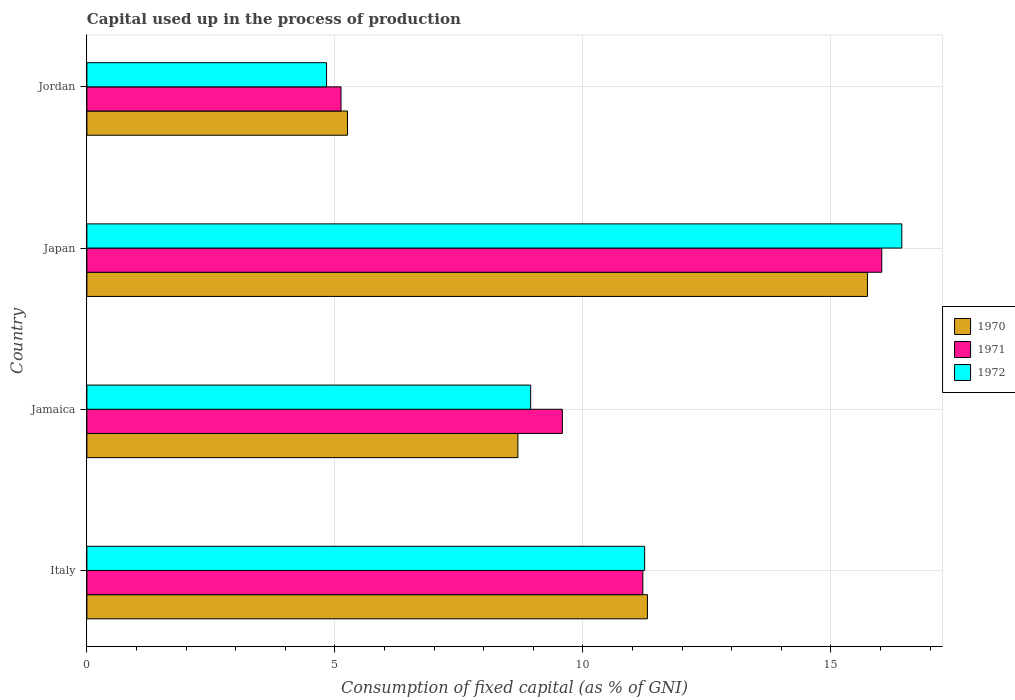How many different coloured bars are there?
Provide a succinct answer. 3. Are the number of bars per tick equal to the number of legend labels?
Offer a very short reply. Yes. What is the label of the 2nd group of bars from the top?
Your response must be concise. Japan. What is the capital used up in the process of production in 1972 in Jordan?
Provide a short and direct response. 4.83. Across all countries, what is the maximum capital used up in the process of production in 1970?
Provide a short and direct response. 15.74. Across all countries, what is the minimum capital used up in the process of production in 1972?
Your answer should be compact. 4.83. In which country was the capital used up in the process of production in 1972 maximum?
Offer a terse response. Japan. In which country was the capital used up in the process of production in 1971 minimum?
Give a very brief answer. Jordan. What is the total capital used up in the process of production in 1972 in the graph?
Ensure brevity in your answer.  41.45. What is the difference between the capital used up in the process of production in 1971 in Japan and that in Jordan?
Give a very brief answer. 10.9. What is the difference between the capital used up in the process of production in 1972 in Italy and the capital used up in the process of production in 1971 in Jordan?
Give a very brief answer. 6.12. What is the average capital used up in the process of production in 1972 per country?
Your answer should be very brief. 10.36. What is the difference between the capital used up in the process of production in 1970 and capital used up in the process of production in 1972 in Jordan?
Provide a succinct answer. 0.42. What is the ratio of the capital used up in the process of production in 1972 in Jamaica to that in Jordan?
Your answer should be very brief. 1.85. Is the capital used up in the process of production in 1970 in Italy less than that in Jordan?
Provide a short and direct response. No. Is the difference between the capital used up in the process of production in 1970 in Japan and Jordan greater than the difference between the capital used up in the process of production in 1972 in Japan and Jordan?
Your answer should be very brief. No. What is the difference between the highest and the second highest capital used up in the process of production in 1972?
Provide a succinct answer. 5.18. What is the difference between the highest and the lowest capital used up in the process of production in 1971?
Offer a terse response. 10.9. In how many countries, is the capital used up in the process of production in 1972 greater than the average capital used up in the process of production in 1972 taken over all countries?
Give a very brief answer. 2. Is the sum of the capital used up in the process of production in 1971 in Italy and Jordan greater than the maximum capital used up in the process of production in 1970 across all countries?
Your response must be concise. Yes. How many bars are there?
Offer a very short reply. 12. Are all the bars in the graph horizontal?
Keep it short and to the point. Yes. What is the difference between two consecutive major ticks on the X-axis?
Your answer should be very brief. 5. Are the values on the major ticks of X-axis written in scientific E-notation?
Your answer should be compact. No. Does the graph contain grids?
Offer a terse response. Yes. Where does the legend appear in the graph?
Your answer should be very brief. Center right. How many legend labels are there?
Offer a terse response. 3. How are the legend labels stacked?
Make the answer very short. Vertical. What is the title of the graph?
Offer a terse response. Capital used up in the process of production. Does "1961" appear as one of the legend labels in the graph?
Your answer should be compact. No. What is the label or title of the X-axis?
Your answer should be very brief. Consumption of fixed capital (as % of GNI). What is the Consumption of fixed capital (as % of GNI) of 1970 in Italy?
Offer a terse response. 11.3. What is the Consumption of fixed capital (as % of GNI) in 1971 in Italy?
Offer a very short reply. 11.21. What is the Consumption of fixed capital (as % of GNI) in 1972 in Italy?
Provide a succinct answer. 11.24. What is the Consumption of fixed capital (as % of GNI) of 1970 in Jamaica?
Offer a terse response. 8.69. What is the Consumption of fixed capital (as % of GNI) in 1971 in Jamaica?
Your answer should be compact. 9.58. What is the Consumption of fixed capital (as % of GNI) of 1972 in Jamaica?
Make the answer very short. 8.95. What is the Consumption of fixed capital (as % of GNI) of 1970 in Japan?
Make the answer very short. 15.74. What is the Consumption of fixed capital (as % of GNI) in 1971 in Japan?
Provide a short and direct response. 16.02. What is the Consumption of fixed capital (as % of GNI) of 1972 in Japan?
Your answer should be compact. 16.43. What is the Consumption of fixed capital (as % of GNI) of 1970 in Jordan?
Provide a succinct answer. 5.25. What is the Consumption of fixed capital (as % of GNI) in 1971 in Jordan?
Give a very brief answer. 5.12. What is the Consumption of fixed capital (as % of GNI) of 1972 in Jordan?
Your answer should be very brief. 4.83. Across all countries, what is the maximum Consumption of fixed capital (as % of GNI) in 1970?
Give a very brief answer. 15.74. Across all countries, what is the maximum Consumption of fixed capital (as % of GNI) of 1971?
Make the answer very short. 16.02. Across all countries, what is the maximum Consumption of fixed capital (as % of GNI) in 1972?
Your response must be concise. 16.43. Across all countries, what is the minimum Consumption of fixed capital (as % of GNI) of 1970?
Offer a terse response. 5.25. Across all countries, what is the minimum Consumption of fixed capital (as % of GNI) of 1971?
Ensure brevity in your answer.  5.12. Across all countries, what is the minimum Consumption of fixed capital (as % of GNI) in 1972?
Offer a very short reply. 4.83. What is the total Consumption of fixed capital (as % of GNI) of 1970 in the graph?
Keep it short and to the point. 40.98. What is the total Consumption of fixed capital (as % of GNI) in 1971 in the graph?
Your answer should be compact. 41.94. What is the total Consumption of fixed capital (as % of GNI) of 1972 in the graph?
Your response must be concise. 41.45. What is the difference between the Consumption of fixed capital (as % of GNI) of 1970 in Italy and that in Jamaica?
Provide a succinct answer. 2.61. What is the difference between the Consumption of fixed capital (as % of GNI) in 1971 in Italy and that in Jamaica?
Your answer should be very brief. 1.62. What is the difference between the Consumption of fixed capital (as % of GNI) of 1972 in Italy and that in Jamaica?
Your answer should be compact. 2.3. What is the difference between the Consumption of fixed capital (as % of GNI) of 1970 in Italy and that in Japan?
Offer a terse response. -4.44. What is the difference between the Consumption of fixed capital (as % of GNI) of 1971 in Italy and that in Japan?
Give a very brief answer. -4.82. What is the difference between the Consumption of fixed capital (as % of GNI) in 1972 in Italy and that in Japan?
Ensure brevity in your answer.  -5.18. What is the difference between the Consumption of fixed capital (as % of GNI) in 1970 in Italy and that in Jordan?
Keep it short and to the point. 6.05. What is the difference between the Consumption of fixed capital (as % of GNI) of 1971 in Italy and that in Jordan?
Offer a terse response. 6.08. What is the difference between the Consumption of fixed capital (as % of GNI) in 1972 in Italy and that in Jordan?
Provide a short and direct response. 6.41. What is the difference between the Consumption of fixed capital (as % of GNI) in 1970 in Jamaica and that in Japan?
Ensure brevity in your answer.  -7.05. What is the difference between the Consumption of fixed capital (as % of GNI) in 1971 in Jamaica and that in Japan?
Provide a short and direct response. -6.44. What is the difference between the Consumption of fixed capital (as % of GNI) in 1972 in Jamaica and that in Japan?
Your answer should be very brief. -7.48. What is the difference between the Consumption of fixed capital (as % of GNI) of 1970 in Jamaica and that in Jordan?
Your response must be concise. 3.44. What is the difference between the Consumption of fixed capital (as % of GNI) in 1971 in Jamaica and that in Jordan?
Your answer should be very brief. 4.46. What is the difference between the Consumption of fixed capital (as % of GNI) in 1972 in Jamaica and that in Jordan?
Make the answer very short. 4.11. What is the difference between the Consumption of fixed capital (as % of GNI) in 1970 in Japan and that in Jordan?
Give a very brief answer. 10.48. What is the difference between the Consumption of fixed capital (as % of GNI) in 1971 in Japan and that in Jordan?
Keep it short and to the point. 10.9. What is the difference between the Consumption of fixed capital (as % of GNI) of 1972 in Japan and that in Jordan?
Your response must be concise. 11.6. What is the difference between the Consumption of fixed capital (as % of GNI) of 1970 in Italy and the Consumption of fixed capital (as % of GNI) of 1971 in Jamaica?
Offer a very short reply. 1.72. What is the difference between the Consumption of fixed capital (as % of GNI) of 1970 in Italy and the Consumption of fixed capital (as % of GNI) of 1972 in Jamaica?
Ensure brevity in your answer.  2.35. What is the difference between the Consumption of fixed capital (as % of GNI) of 1971 in Italy and the Consumption of fixed capital (as % of GNI) of 1972 in Jamaica?
Provide a short and direct response. 2.26. What is the difference between the Consumption of fixed capital (as % of GNI) of 1970 in Italy and the Consumption of fixed capital (as % of GNI) of 1971 in Japan?
Your response must be concise. -4.72. What is the difference between the Consumption of fixed capital (as % of GNI) in 1970 in Italy and the Consumption of fixed capital (as % of GNI) in 1972 in Japan?
Ensure brevity in your answer.  -5.13. What is the difference between the Consumption of fixed capital (as % of GNI) in 1971 in Italy and the Consumption of fixed capital (as % of GNI) in 1972 in Japan?
Give a very brief answer. -5.22. What is the difference between the Consumption of fixed capital (as % of GNI) in 1970 in Italy and the Consumption of fixed capital (as % of GNI) in 1971 in Jordan?
Give a very brief answer. 6.18. What is the difference between the Consumption of fixed capital (as % of GNI) in 1970 in Italy and the Consumption of fixed capital (as % of GNI) in 1972 in Jordan?
Your answer should be compact. 6.47. What is the difference between the Consumption of fixed capital (as % of GNI) of 1971 in Italy and the Consumption of fixed capital (as % of GNI) of 1972 in Jordan?
Offer a terse response. 6.38. What is the difference between the Consumption of fixed capital (as % of GNI) of 1970 in Jamaica and the Consumption of fixed capital (as % of GNI) of 1971 in Japan?
Make the answer very short. -7.34. What is the difference between the Consumption of fixed capital (as % of GNI) in 1970 in Jamaica and the Consumption of fixed capital (as % of GNI) in 1972 in Japan?
Keep it short and to the point. -7.74. What is the difference between the Consumption of fixed capital (as % of GNI) of 1971 in Jamaica and the Consumption of fixed capital (as % of GNI) of 1972 in Japan?
Provide a short and direct response. -6.84. What is the difference between the Consumption of fixed capital (as % of GNI) of 1970 in Jamaica and the Consumption of fixed capital (as % of GNI) of 1971 in Jordan?
Offer a very short reply. 3.57. What is the difference between the Consumption of fixed capital (as % of GNI) of 1970 in Jamaica and the Consumption of fixed capital (as % of GNI) of 1972 in Jordan?
Keep it short and to the point. 3.86. What is the difference between the Consumption of fixed capital (as % of GNI) in 1971 in Jamaica and the Consumption of fixed capital (as % of GNI) in 1972 in Jordan?
Give a very brief answer. 4.75. What is the difference between the Consumption of fixed capital (as % of GNI) in 1970 in Japan and the Consumption of fixed capital (as % of GNI) in 1971 in Jordan?
Provide a succinct answer. 10.61. What is the difference between the Consumption of fixed capital (as % of GNI) of 1970 in Japan and the Consumption of fixed capital (as % of GNI) of 1972 in Jordan?
Give a very brief answer. 10.9. What is the difference between the Consumption of fixed capital (as % of GNI) in 1971 in Japan and the Consumption of fixed capital (as % of GNI) in 1972 in Jordan?
Ensure brevity in your answer.  11.19. What is the average Consumption of fixed capital (as % of GNI) in 1970 per country?
Your answer should be compact. 10.24. What is the average Consumption of fixed capital (as % of GNI) of 1971 per country?
Provide a succinct answer. 10.48. What is the average Consumption of fixed capital (as % of GNI) in 1972 per country?
Offer a very short reply. 10.36. What is the difference between the Consumption of fixed capital (as % of GNI) in 1970 and Consumption of fixed capital (as % of GNI) in 1971 in Italy?
Offer a terse response. 0.09. What is the difference between the Consumption of fixed capital (as % of GNI) in 1970 and Consumption of fixed capital (as % of GNI) in 1972 in Italy?
Your answer should be compact. 0.06. What is the difference between the Consumption of fixed capital (as % of GNI) of 1971 and Consumption of fixed capital (as % of GNI) of 1972 in Italy?
Ensure brevity in your answer.  -0.04. What is the difference between the Consumption of fixed capital (as % of GNI) in 1970 and Consumption of fixed capital (as % of GNI) in 1971 in Jamaica?
Provide a short and direct response. -0.9. What is the difference between the Consumption of fixed capital (as % of GNI) in 1970 and Consumption of fixed capital (as % of GNI) in 1972 in Jamaica?
Make the answer very short. -0.26. What is the difference between the Consumption of fixed capital (as % of GNI) in 1971 and Consumption of fixed capital (as % of GNI) in 1972 in Jamaica?
Provide a succinct answer. 0.64. What is the difference between the Consumption of fixed capital (as % of GNI) in 1970 and Consumption of fixed capital (as % of GNI) in 1971 in Japan?
Your answer should be compact. -0.29. What is the difference between the Consumption of fixed capital (as % of GNI) in 1970 and Consumption of fixed capital (as % of GNI) in 1972 in Japan?
Give a very brief answer. -0.69. What is the difference between the Consumption of fixed capital (as % of GNI) in 1971 and Consumption of fixed capital (as % of GNI) in 1972 in Japan?
Make the answer very short. -0.4. What is the difference between the Consumption of fixed capital (as % of GNI) in 1970 and Consumption of fixed capital (as % of GNI) in 1971 in Jordan?
Your response must be concise. 0.13. What is the difference between the Consumption of fixed capital (as % of GNI) in 1970 and Consumption of fixed capital (as % of GNI) in 1972 in Jordan?
Your response must be concise. 0.42. What is the difference between the Consumption of fixed capital (as % of GNI) in 1971 and Consumption of fixed capital (as % of GNI) in 1972 in Jordan?
Your answer should be compact. 0.29. What is the ratio of the Consumption of fixed capital (as % of GNI) of 1970 in Italy to that in Jamaica?
Offer a terse response. 1.3. What is the ratio of the Consumption of fixed capital (as % of GNI) in 1971 in Italy to that in Jamaica?
Offer a terse response. 1.17. What is the ratio of the Consumption of fixed capital (as % of GNI) of 1972 in Italy to that in Jamaica?
Your answer should be compact. 1.26. What is the ratio of the Consumption of fixed capital (as % of GNI) in 1970 in Italy to that in Japan?
Your answer should be compact. 0.72. What is the ratio of the Consumption of fixed capital (as % of GNI) of 1971 in Italy to that in Japan?
Make the answer very short. 0.7. What is the ratio of the Consumption of fixed capital (as % of GNI) of 1972 in Italy to that in Japan?
Offer a very short reply. 0.68. What is the ratio of the Consumption of fixed capital (as % of GNI) in 1970 in Italy to that in Jordan?
Provide a short and direct response. 2.15. What is the ratio of the Consumption of fixed capital (as % of GNI) in 1971 in Italy to that in Jordan?
Ensure brevity in your answer.  2.19. What is the ratio of the Consumption of fixed capital (as % of GNI) in 1972 in Italy to that in Jordan?
Offer a very short reply. 2.33. What is the ratio of the Consumption of fixed capital (as % of GNI) of 1970 in Jamaica to that in Japan?
Your answer should be compact. 0.55. What is the ratio of the Consumption of fixed capital (as % of GNI) of 1971 in Jamaica to that in Japan?
Your answer should be very brief. 0.6. What is the ratio of the Consumption of fixed capital (as % of GNI) of 1972 in Jamaica to that in Japan?
Offer a terse response. 0.54. What is the ratio of the Consumption of fixed capital (as % of GNI) of 1970 in Jamaica to that in Jordan?
Offer a terse response. 1.65. What is the ratio of the Consumption of fixed capital (as % of GNI) of 1971 in Jamaica to that in Jordan?
Offer a very short reply. 1.87. What is the ratio of the Consumption of fixed capital (as % of GNI) in 1972 in Jamaica to that in Jordan?
Ensure brevity in your answer.  1.85. What is the ratio of the Consumption of fixed capital (as % of GNI) in 1970 in Japan to that in Jordan?
Provide a succinct answer. 3. What is the ratio of the Consumption of fixed capital (as % of GNI) in 1971 in Japan to that in Jordan?
Keep it short and to the point. 3.13. What is the ratio of the Consumption of fixed capital (as % of GNI) of 1972 in Japan to that in Jordan?
Offer a terse response. 3.4. What is the difference between the highest and the second highest Consumption of fixed capital (as % of GNI) in 1970?
Keep it short and to the point. 4.44. What is the difference between the highest and the second highest Consumption of fixed capital (as % of GNI) of 1971?
Offer a terse response. 4.82. What is the difference between the highest and the second highest Consumption of fixed capital (as % of GNI) in 1972?
Offer a terse response. 5.18. What is the difference between the highest and the lowest Consumption of fixed capital (as % of GNI) of 1970?
Offer a very short reply. 10.48. What is the difference between the highest and the lowest Consumption of fixed capital (as % of GNI) of 1971?
Your answer should be compact. 10.9. What is the difference between the highest and the lowest Consumption of fixed capital (as % of GNI) of 1972?
Provide a short and direct response. 11.6. 